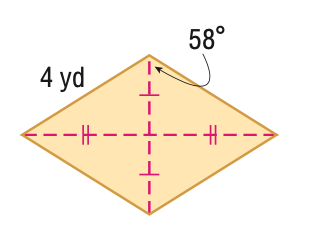Question: Find the perimeter of the figure in feet. Round to the nearest tenth, if necessary.
Choices:
A. 8
B. 14.4
C. 16
D. 18.9
Answer with the letter. Answer: C 